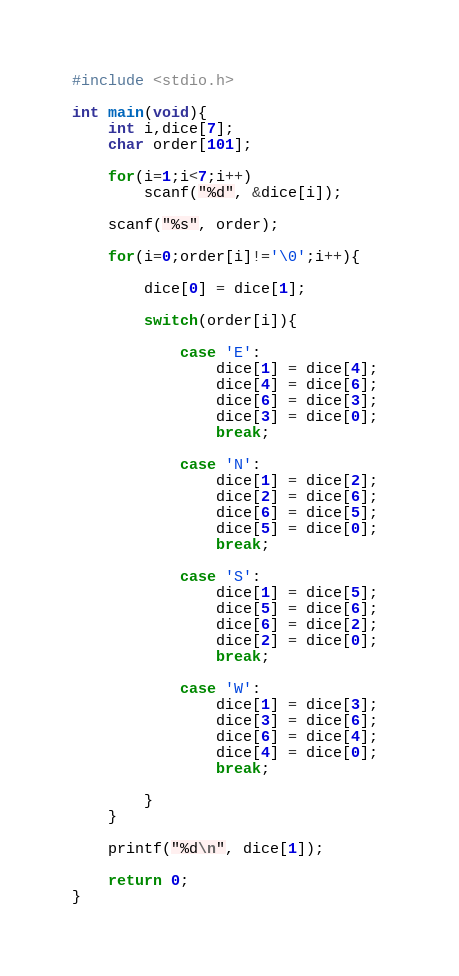<code> <loc_0><loc_0><loc_500><loc_500><_C_>#include <stdio.h>
 
int main(void){
    int i,dice[7];
    char order[101];
     
    for(i=1;i<7;i++)
        scanf("%d", &dice[i]);
     
    scanf("%s", order);
     
    for(i=0;order[i]!='\0';i++){
         
        dice[0] = dice[1];
         
        switch(order[i]){
                 
            case 'E':
                dice[1] = dice[4];
                dice[4] = dice[6];
                dice[6] = dice[3];
                dice[3] = dice[0]; 
                break;
             
            case 'N':
                dice[1] = dice[2];
                dice[2] = dice[6];
                dice[6] = dice[5];
                dice[5] = dice[0]; 
                break;
             
            case 'S':
                dice[1] = dice[5];
                dice[5] = dice[6];
                dice[6] = dice[2];
                dice[2] = dice[0]; 
                break;
                 
            case 'W':
                dice[1] = dice[3];
                dice[3] = dice[6];
                dice[6] = dice[4];
                dice[4] = dice[0]; 
                break;
 
        }
    }
     
    printf("%d\n", dice[1]);
     
    return 0;
}
</code> 